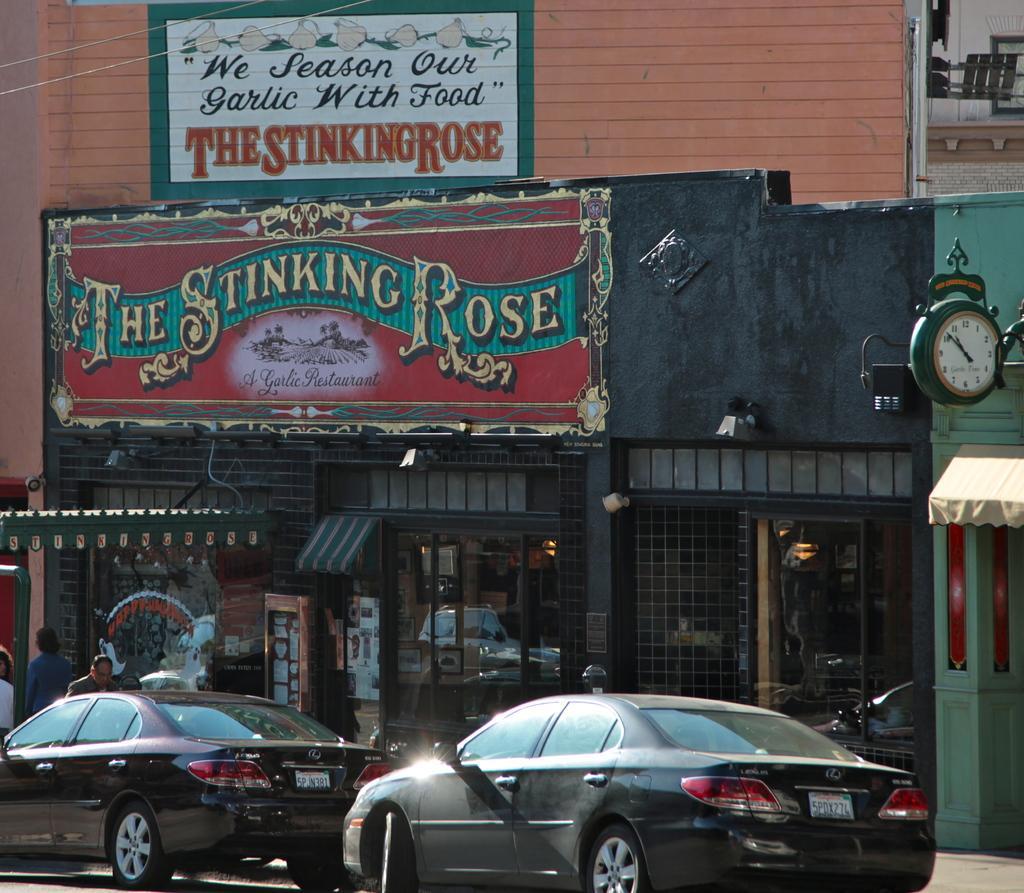How would you summarize this image in a sentence or two? In this picture we can see cars on the road, building, wall, clock, sun shade and some people. 